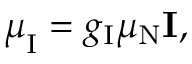Convert formula to latex. <formula><loc_0><loc_0><loc_500><loc_500>{ \mu } _ { I } = g _ { I } \mu _ { N } I ,</formula> 